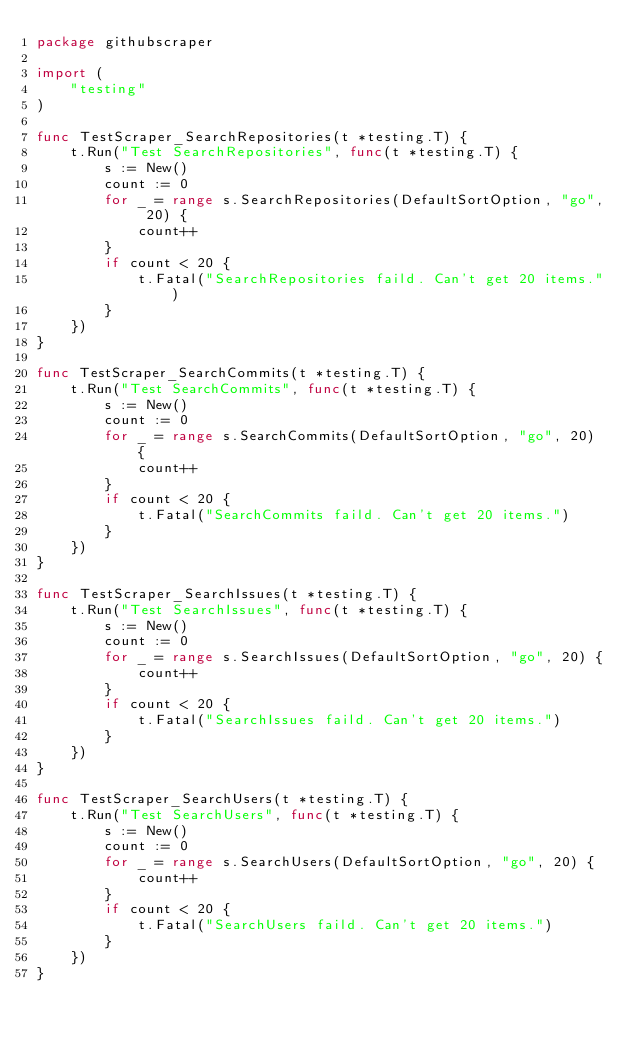<code> <loc_0><loc_0><loc_500><loc_500><_Go_>package githubscraper

import (
	"testing"
)

func TestScraper_SearchRepositories(t *testing.T) {
	t.Run("Test SearchRepositories", func(t *testing.T) {
		s := New()
		count := 0
		for _ = range s.SearchRepositories(DefaultSortOption, "go", 20) {
			count++
		}
		if count < 20 {
			t.Fatal("SearchRepositories faild. Can't get 20 items.")
		}
	})
}

func TestScraper_SearchCommits(t *testing.T) {
	t.Run("Test SearchCommits", func(t *testing.T) {
		s := New()
		count := 0
		for _ = range s.SearchCommits(DefaultSortOption, "go", 20) {
			count++
		}
		if count < 20 {
			t.Fatal("SearchCommits faild. Can't get 20 items.")
		}
	})
}

func TestScraper_SearchIssues(t *testing.T) {
	t.Run("Test SearchIssues", func(t *testing.T) {
		s := New()
		count := 0
		for _ = range s.SearchIssues(DefaultSortOption, "go", 20) {
			count++
		}
		if count < 20 {
			t.Fatal("SearchIssues faild. Can't get 20 items.")
		}
	})
}

func TestScraper_SearchUsers(t *testing.T) {
	t.Run("Test SearchUsers", func(t *testing.T) {
		s := New()
		count := 0
		for _ = range s.SearchUsers(DefaultSortOption, "go", 20) {
			count++
		}
		if count < 20 {
			t.Fatal("SearchUsers faild. Can't get 20 items.")
		}
	})
}
</code> 